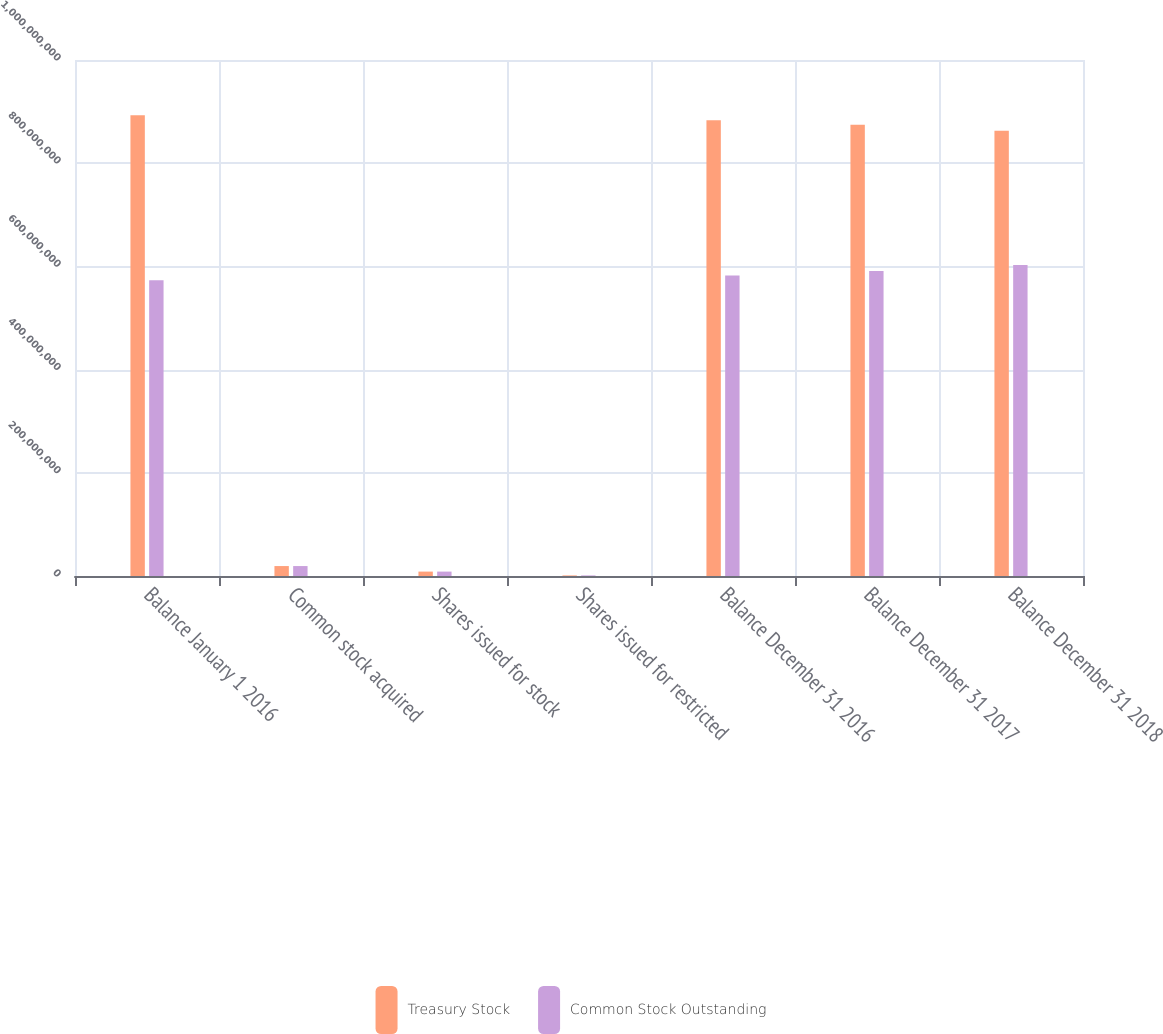Convert chart. <chart><loc_0><loc_0><loc_500><loc_500><stacked_bar_chart><ecel><fcel>Balance January 1 2016<fcel>Common stock acquired<fcel>Shares issued for stock<fcel>Shares issued for restricted<fcel>Balance December 31 2016<fcel>Balance December 31 2017<fcel>Balance December 31 2018<nl><fcel>Treasury Stock<fcel>8.92739e+08<fcel>1.92713e+07<fcel>8.53664e+06<fcel>1.10511e+06<fcel>8.83109e+08<fcel>8.74701e+08<fcel>8.62913e+08<nl><fcel>Common Stock Outstanding<fcel>5.72968e+08<fcel>1.92713e+07<fcel>8.53664e+06<fcel>1.10511e+06<fcel>5.82597e+08<fcel>5.91005e+08<fcel>6.02794e+08<nl></chart> 